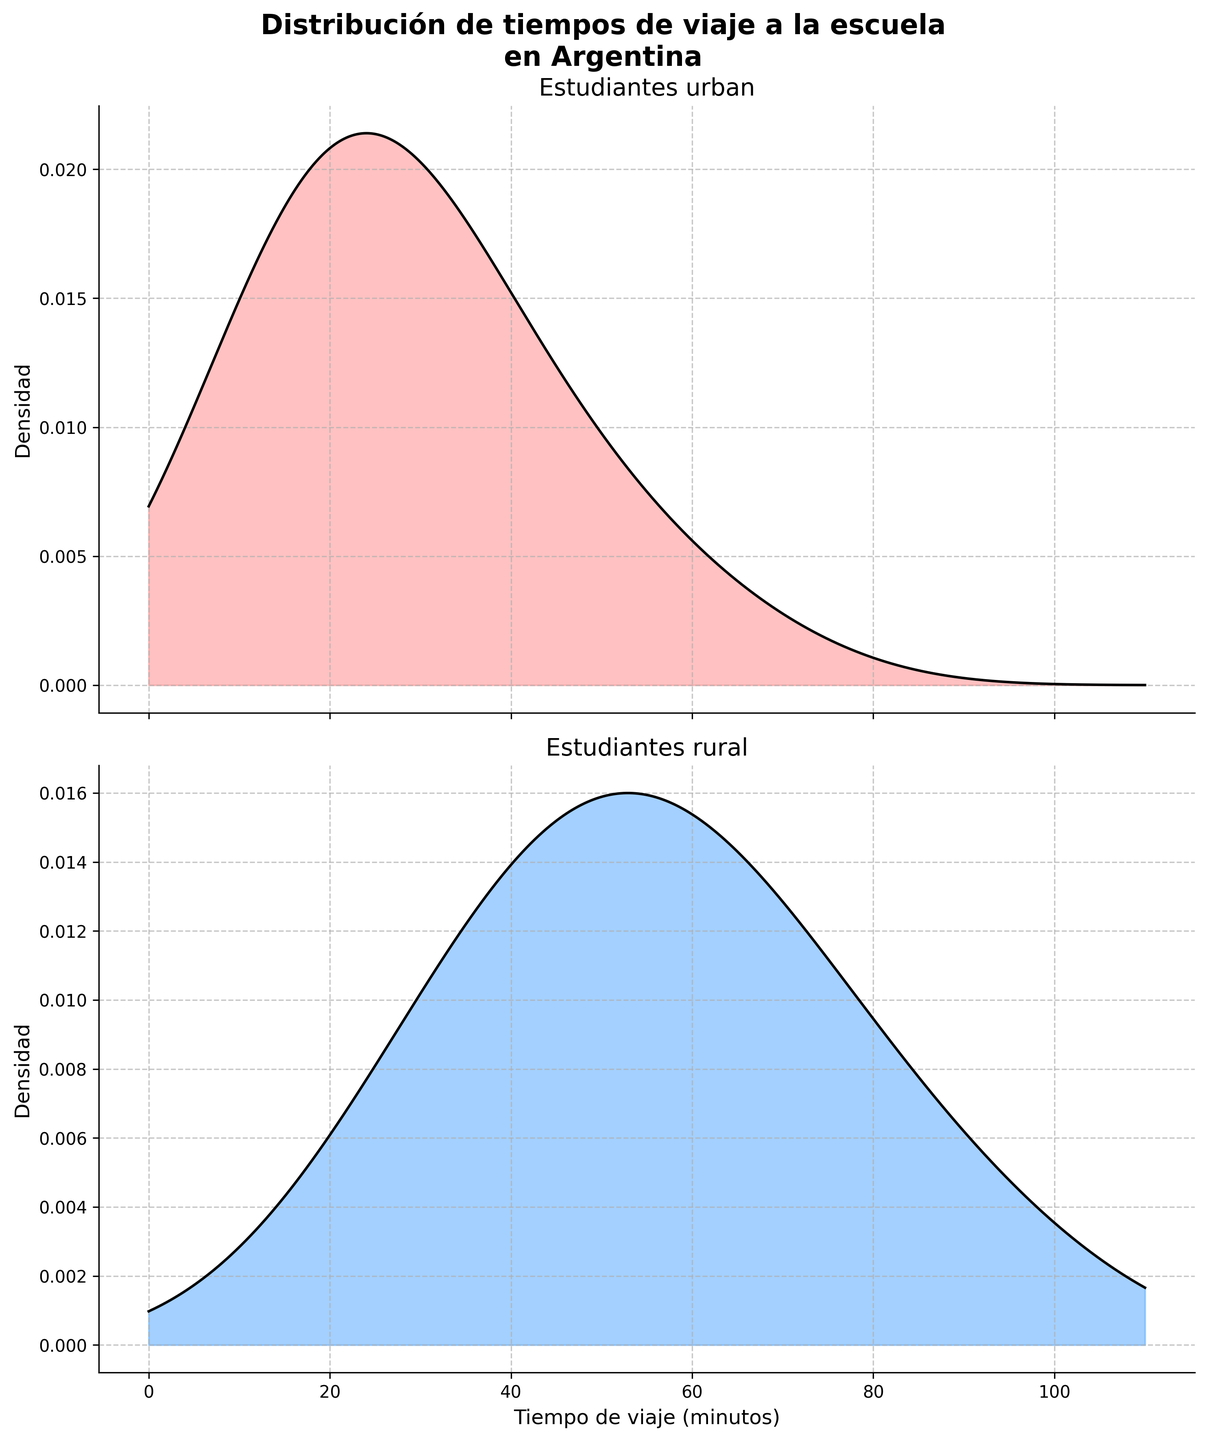What is the title of the figure? The title is displayed at the top of the figure. It states "Distribución de tiempos de viaje a la escuela en Argentina".
Answer: Distribución de tiempos de viaje a la escuela en Argentina What do the two subplots represent? The two subplots are labeled as "Estudiantes urban" and "Estudiantes rural". They represent the distribution of travel times to school for urban and rural students in Argentina, respectively.
Answer: Distribution of travel times for urban and rural students Which subplot shows students with generally shorter travel times? Comparing the two subplots, the urban students' density plot has a higher peak at shorter travel times compared to the rural students' plot.
Answer: Urban What is the approximate peak density value for the urban students? The peak of the urban students’ density plot appears to be just below 0.04.
Answer: Just below 0.04 Why is the urban subplot's peak located at a lower travel time than the rural subplot's peak? The urban plot peaks at a lower travel time because urban students typically have shorter travel times to school due to closer proximity to educational institutions compared to rural students.
Answer: Closer proximity to schools At what travel times do the peaks of the rural and urban density plots occur? The peak for the urban plot occurs close to 20 minutes, while the peak for the rural plot occurs close to 50 minutes.
Answer: 20 minutes (urban), 50 minutes (rural) Between which travel times does the rural subplot show an almost steady density? The rural subplot shows a relatively steady density between approximately 40 and 70 minutes.
Answer: 40 and 70 minutes What kind of data visualization technique is used in these subplots? The technique used in these subplots is density plots, often also called KDE (Kernel Density Estimation) plots.
Answer: Density plots (KDE) What can be inferred about urban vs rural travel times greater than 70 minutes? From the density plots, it is visible that travel times greater than 70 minutes are more common for rural students than for urban students, as the rural plot maintains density while the urban plot density decreases significantly.
Answer: More common for rural Do rural or urban students show a greater variety of travel times? The rural students show a greater variety in travel times distribution, as the density plot for rural students is spread over a wider range of travel times compared to the urban students’ density plot which is more narrowly concentrated around shorter travel times.
Answer: Rural Which group has almost no students with travel times less than 20 minutes? The density plot for rural students shows that there are almost no students with travel times of less than 20 minutes, as the density starts to rise only after this value.
Answer: Rural 